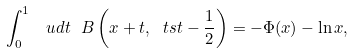<formula> <loc_0><loc_0><loc_500><loc_500>\int _ { 0 } ^ { 1 } \, \ u d t \ B \left ( x + t , { \ t s t - \frac { 1 } { 2 } } \right ) = - \Phi ( x ) - \ln x ,</formula> 